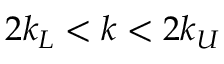<formula> <loc_0><loc_0><loc_500><loc_500>2 k _ { L } < k < 2 k _ { U }</formula> 